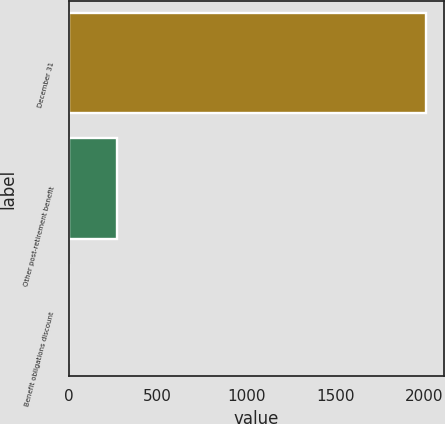Convert chart. <chart><loc_0><loc_0><loc_500><loc_500><bar_chart><fcel>December 31<fcel>Other post-retirement benefit<fcel>Benefit obligations discount<nl><fcel>2013<fcel>270.9<fcel>4.5<nl></chart> 